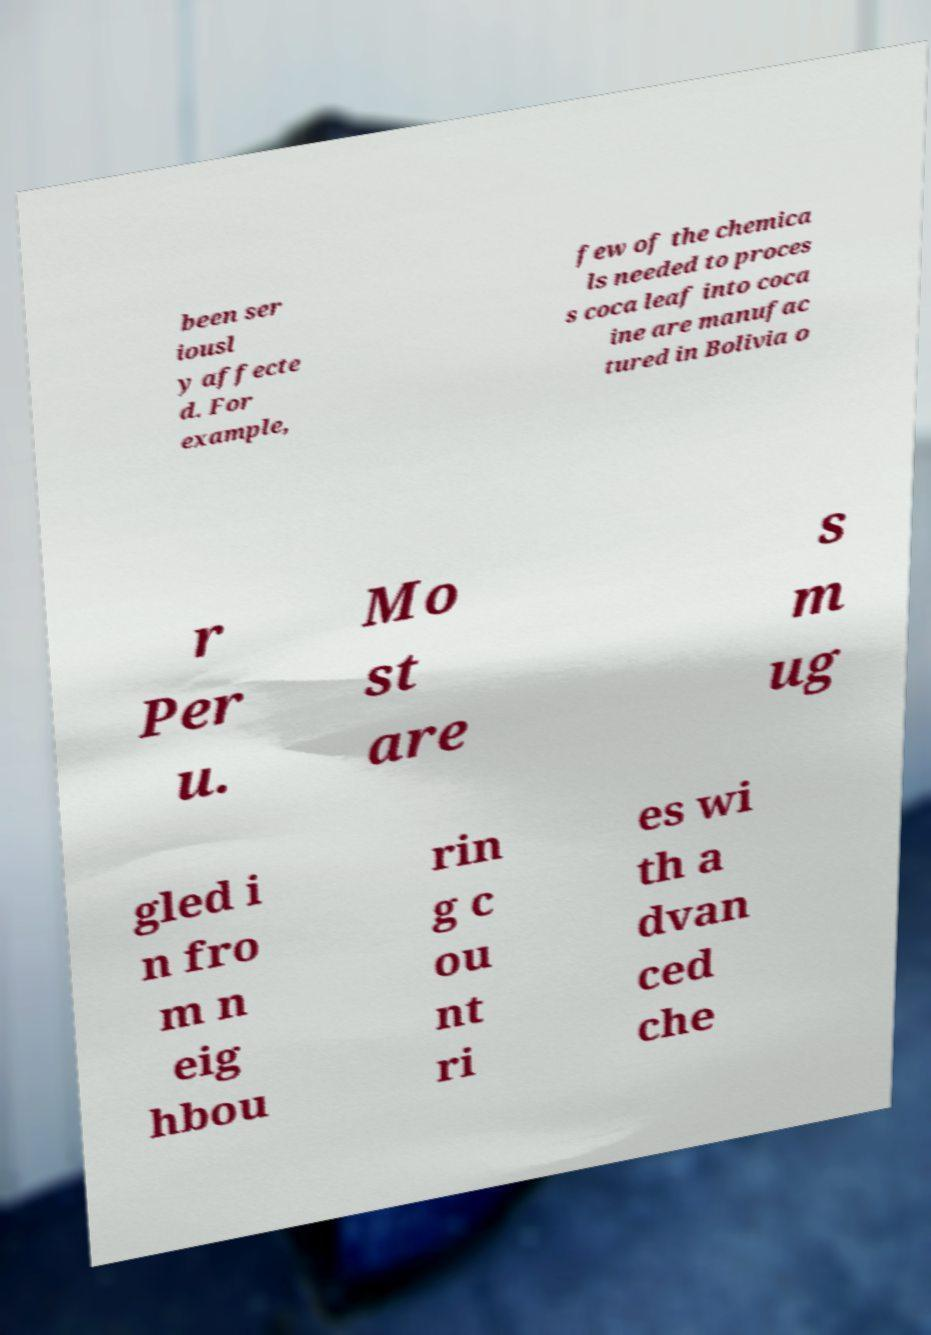Could you assist in decoding the text presented in this image and type it out clearly? been ser iousl y affecte d. For example, few of the chemica ls needed to proces s coca leaf into coca ine are manufac tured in Bolivia o r Per u. Mo st are s m ug gled i n fro m n eig hbou rin g c ou nt ri es wi th a dvan ced che 